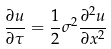<formula> <loc_0><loc_0><loc_500><loc_500>\frac { \partial u } { \partial \tau } = \frac { 1 } { 2 } \sigma ^ { 2 } \frac { \partial ^ { 2 } u } { \partial x ^ { 2 } }</formula> 